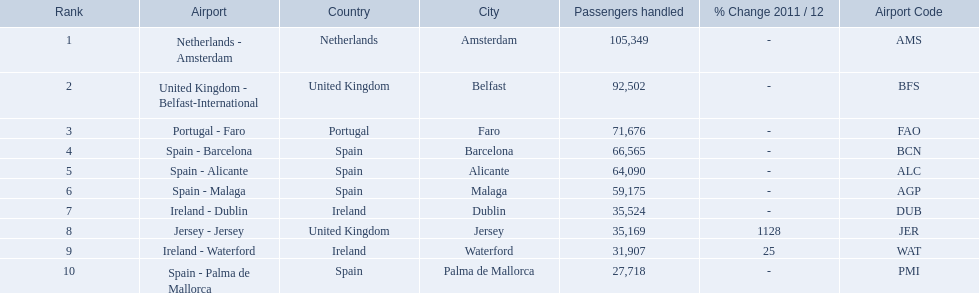Which airports had passengers going through london southend airport? Netherlands - Amsterdam, United Kingdom - Belfast-International, Portugal - Faro, Spain - Barcelona, Spain - Alicante, Spain - Malaga, Ireland - Dublin, Jersey - Jersey, Ireland - Waterford, Spain - Palma de Mallorca. Of those airports, which airport had the least amount of passengers going through london southend airport? Spain - Palma de Mallorca. What are all of the routes out of the london southend airport? Netherlands - Amsterdam, United Kingdom - Belfast-International, Portugal - Faro, Spain - Barcelona, Spain - Alicante, Spain - Malaga, Ireland - Dublin, Jersey - Jersey, Ireland - Waterford, Spain - Palma de Mallorca. How many passengers have traveled to each destination? 105,349, 92,502, 71,676, 66,565, 64,090, 59,175, 35,524, 35,169, 31,907, 27,718. And which destination has been the most popular to passengers? Netherlands - Amsterdam. 